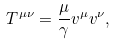<formula> <loc_0><loc_0><loc_500><loc_500>T ^ { \mu \nu } = \frac { \mu } { \gamma } v ^ { \mu } v ^ { \nu } ,</formula> 